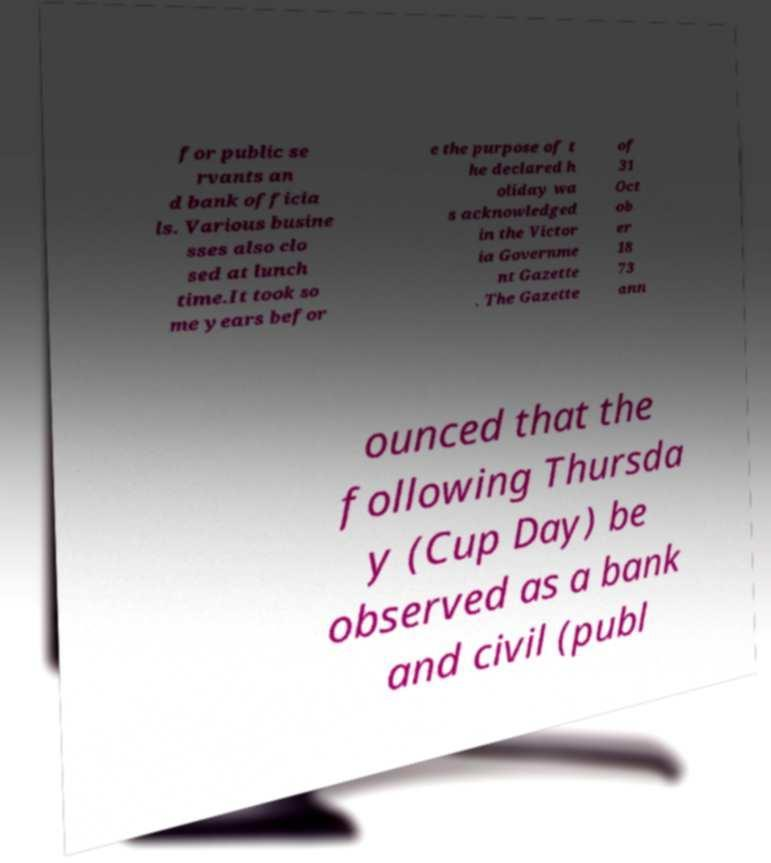Can you read and provide the text displayed in the image?This photo seems to have some interesting text. Can you extract and type it out for me? for public se rvants an d bank officia ls. Various busine sses also clo sed at lunch time.It took so me years befor e the purpose of t he declared h oliday wa s acknowledged in the Victor ia Governme nt Gazette . The Gazette of 31 Oct ob er 18 73 ann ounced that the following Thursda y (Cup Day) be observed as a bank and civil (publ 